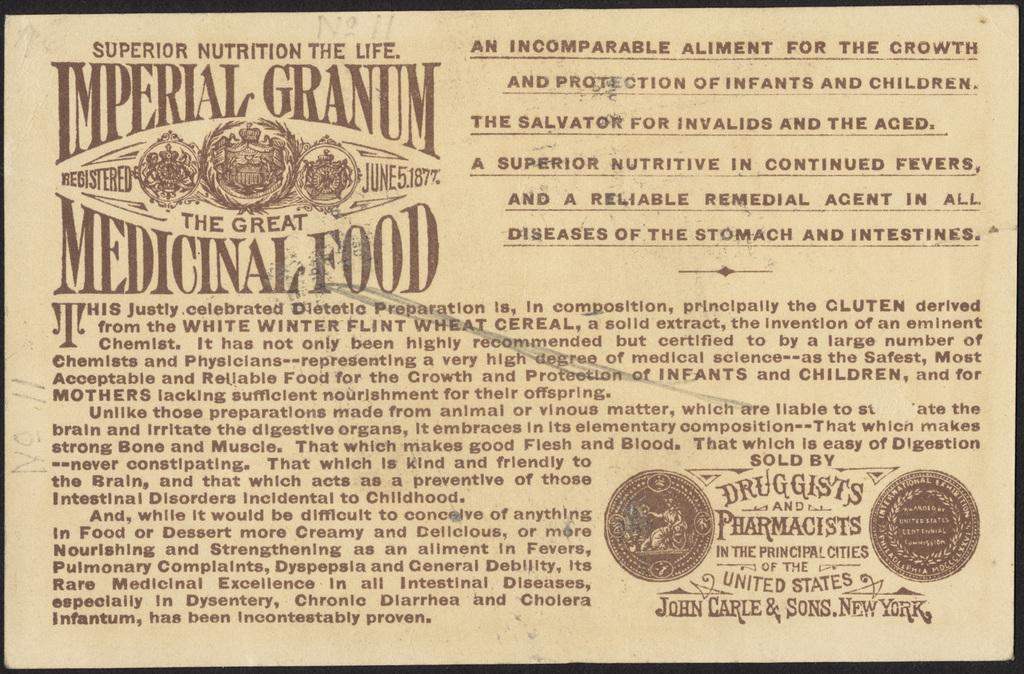<image>
Present a compact description of the photo's key features. An old ad for Imperial Granum, the great medicinal food. 